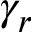<formula> <loc_0><loc_0><loc_500><loc_500>\gamma _ { r }</formula> 